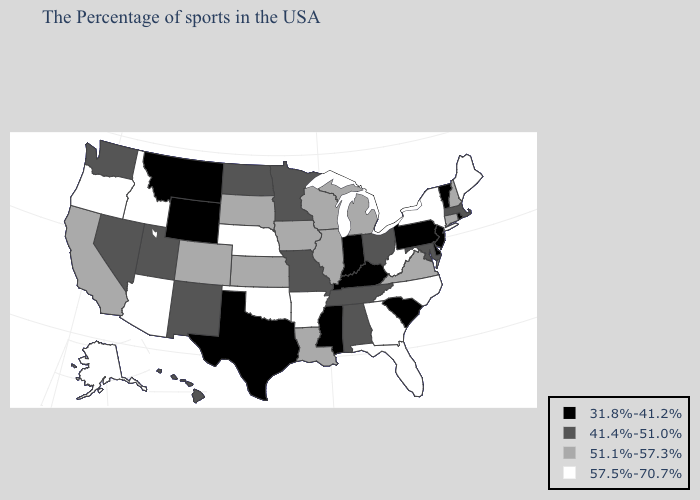Among the states that border New Jersey , does Pennsylvania have the highest value?
Quick response, please. No. What is the lowest value in the South?
Keep it brief. 31.8%-41.2%. Among the states that border Mississippi , which have the lowest value?
Be succinct. Alabama, Tennessee. Does New Jersey have the lowest value in the Northeast?
Quick response, please. Yes. Does the first symbol in the legend represent the smallest category?
Be succinct. Yes. Among the states that border Massachusetts , which have the lowest value?
Short answer required. Rhode Island, Vermont. Which states have the lowest value in the USA?
Answer briefly. Rhode Island, Vermont, New Jersey, Delaware, Pennsylvania, South Carolina, Kentucky, Indiana, Mississippi, Texas, Wyoming, Montana. Name the states that have a value in the range 41.4%-51.0%?
Answer briefly. Massachusetts, Maryland, Ohio, Alabama, Tennessee, Missouri, Minnesota, North Dakota, New Mexico, Utah, Nevada, Washington, Hawaii. Among the states that border Arizona , does California have the highest value?
Write a very short answer. Yes. Name the states that have a value in the range 57.5%-70.7%?
Give a very brief answer. Maine, New York, North Carolina, West Virginia, Florida, Georgia, Arkansas, Nebraska, Oklahoma, Arizona, Idaho, Oregon, Alaska. What is the highest value in the West ?
Write a very short answer. 57.5%-70.7%. Does Indiana have the lowest value in the USA?
Be succinct. Yes. Name the states that have a value in the range 57.5%-70.7%?
Keep it brief. Maine, New York, North Carolina, West Virginia, Florida, Georgia, Arkansas, Nebraska, Oklahoma, Arizona, Idaho, Oregon, Alaska. Does Wisconsin have the same value as Virginia?
Answer briefly. Yes. Does the first symbol in the legend represent the smallest category?
Keep it brief. Yes. 